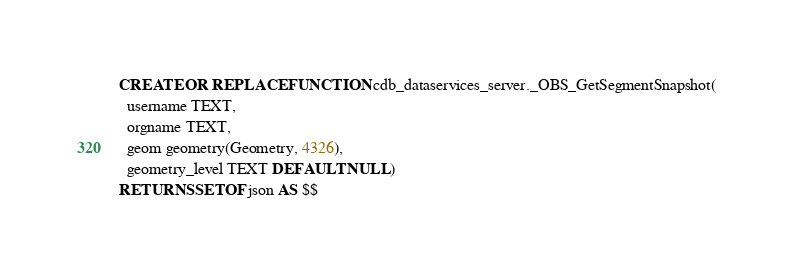Convert code to text. <code><loc_0><loc_0><loc_500><loc_500><_SQL_>
CREATE OR REPLACE FUNCTION cdb_dataservices_server._OBS_GetSegmentSnapshot(
  username TEXT,
  orgname TEXT,
  geom geometry(Geometry, 4326),
  geometry_level TEXT DEFAULT NULL)
RETURNS SETOF json AS $$</code> 